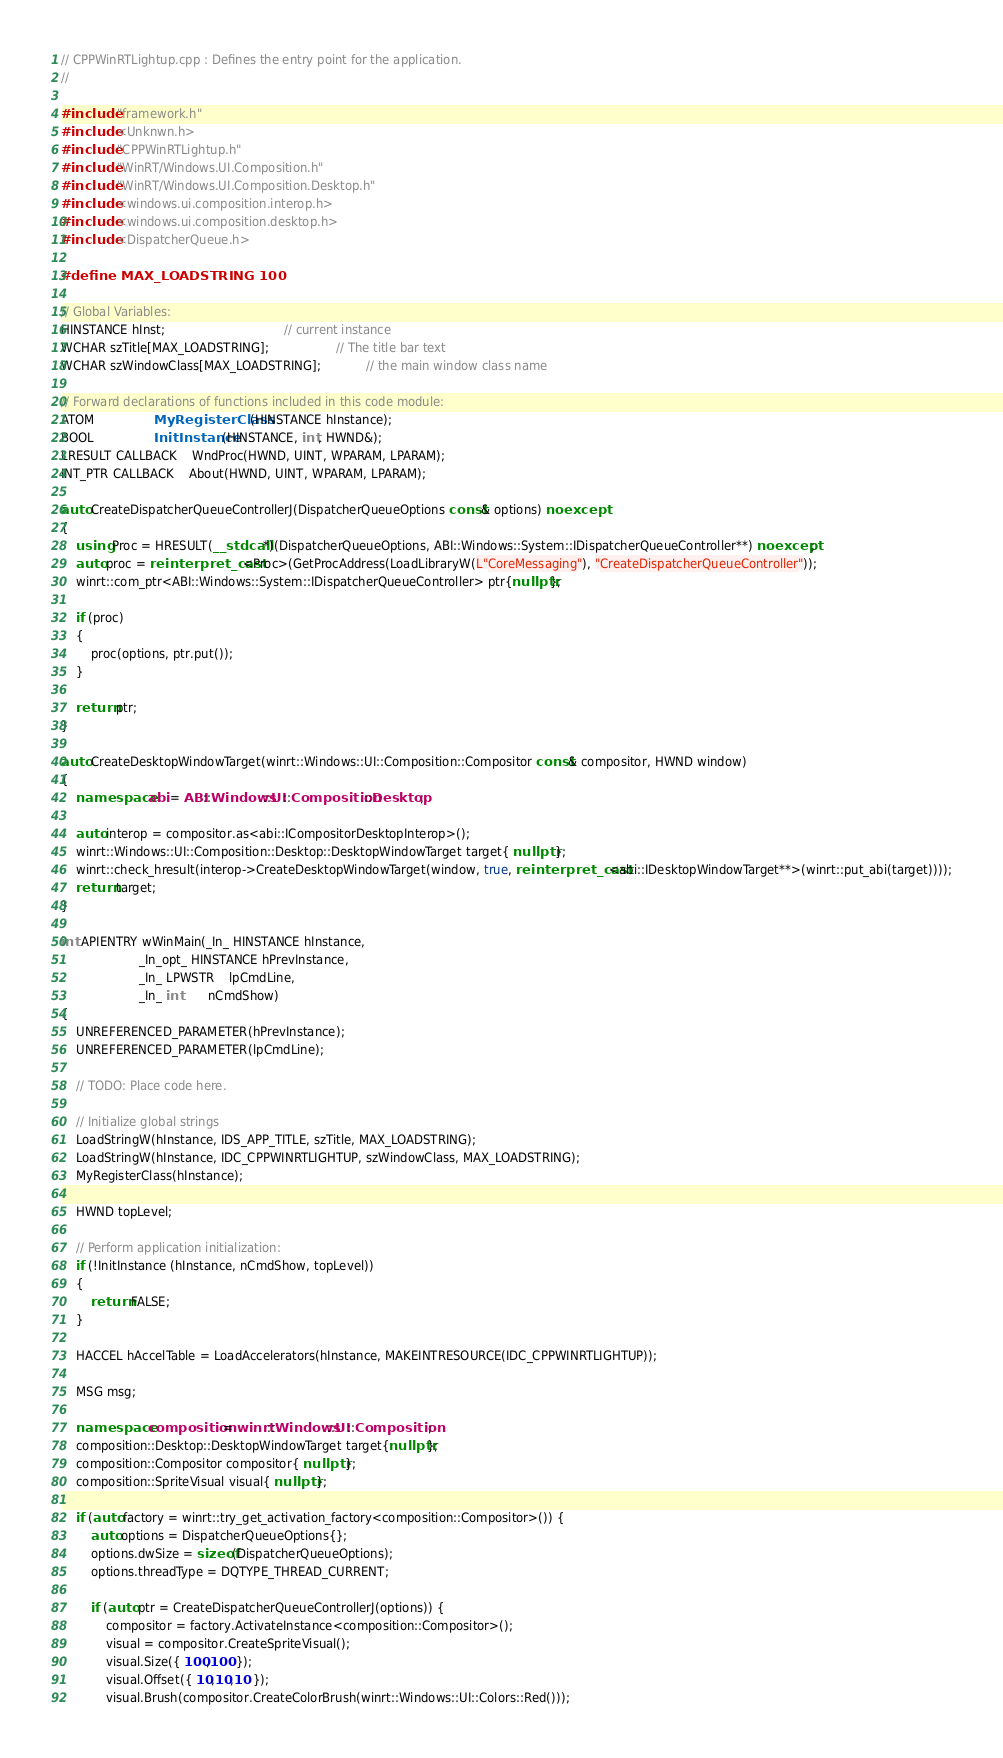<code> <loc_0><loc_0><loc_500><loc_500><_C++_>// CPPWinRTLightup.cpp : Defines the entry point for the application.
//

#include "framework.h"
#include <Unknwn.h>
#include "CPPWinRTLightup.h"
#include "WinRT/Windows.UI.Composition.h"
#include "WinRT/Windows.UI.Composition.Desktop.h"
#include <windows.ui.composition.interop.h>
#include <windows.ui.composition.desktop.h>
#include <DispatcherQueue.h>

#define MAX_LOADSTRING 100

// Global Variables:
HINSTANCE hInst;                                // current instance
WCHAR szTitle[MAX_LOADSTRING];                  // The title bar text
WCHAR szWindowClass[MAX_LOADSTRING];            // the main window class name

// Forward declarations of functions included in this code module:
ATOM                MyRegisterClass(HINSTANCE hInstance);
BOOL                InitInstance(HINSTANCE, int, HWND&);
LRESULT CALLBACK    WndProc(HWND, UINT, WPARAM, LPARAM);
INT_PTR CALLBACK    About(HWND, UINT, WPARAM, LPARAM);

auto CreateDispatcherQueueControllerJ(DispatcherQueueOptions const& options) noexcept
{
    using Proc = HRESULT(__stdcall*)(DispatcherQueueOptions, ABI::Windows::System::IDispatcherQueueController**) noexcept;
    auto proc = reinterpret_cast<Proc>(GetProcAddress(LoadLibraryW(L"CoreMessaging"), "CreateDispatcherQueueController"));
    winrt::com_ptr<ABI::Windows::System::IDispatcherQueueController> ptr{nullptr};

    if (proc)
    {
        proc(options, ptr.put());
    }

    return ptr;
}

auto CreateDesktopWindowTarget(winrt::Windows::UI::Composition::Compositor const& compositor, HWND window)
{
    namespace abi = ABI::Windows::UI::Composition::Desktop;

    auto interop = compositor.as<abi::ICompositorDesktopInterop>();
    winrt::Windows::UI::Composition::Desktop::DesktopWindowTarget target{ nullptr };
    winrt::check_hresult(interop->CreateDesktopWindowTarget(window, true, reinterpret_cast<abi::IDesktopWindowTarget**>(winrt::put_abi(target))));
    return target;
}

int APIENTRY wWinMain(_In_ HINSTANCE hInstance,
                     _In_opt_ HINSTANCE hPrevInstance,
                     _In_ LPWSTR    lpCmdLine,
                     _In_ int       nCmdShow)
{
    UNREFERENCED_PARAMETER(hPrevInstance);
    UNREFERENCED_PARAMETER(lpCmdLine);

    // TODO: Place code here.

    // Initialize global strings
    LoadStringW(hInstance, IDS_APP_TITLE, szTitle, MAX_LOADSTRING);
    LoadStringW(hInstance, IDC_CPPWINRTLIGHTUP, szWindowClass, MAX_LOADSTRING);
    MyRegisterClass(hInstance);

    HWND topLevel;

    // Perform application initialization:
    if (!InitInstance (hInstance, nCmdShow, topLevel))
    {
        return FALSE;
    }

    HACCEL hAccelTable = LoadAccelerators(hInstance, MAKEINTRESOURCE(IDC_CPPWINRTLIGHTUP));

    MSG msg;

    namespace composition = winrt::Windows::UI::Composition;
    composition::Desktop::DesktopWindowTarget target{nullptr};
    composition::Compositor compositor{ nullptr };
    composition::SpriteVisual visual{ nullptr };
    
    if (auto factory = winrt::try_get_activation_factory<composition::Compositor>()) {
        auto options = DispatcherQueueOptions{};
        options.dwSize = sizeof(DispatcherQueueOptions);
        options.threadType = DQTYPE_THREAD_CURRENT;

        if (auto ptr = CreateDispatcherQueueControllerJ(options)) {
            compositor = factory.ActivateInstance<composition::Compositor>();
            visual = compositor.CreateSpriteVisual();
            visual.Size({ 100,100 });
            visual.Offset({ 10,10,10 });
            visual.Brush(compositor.CreateColorBrush(winrt::Windows::UI::Colors::Red()));
</code> 